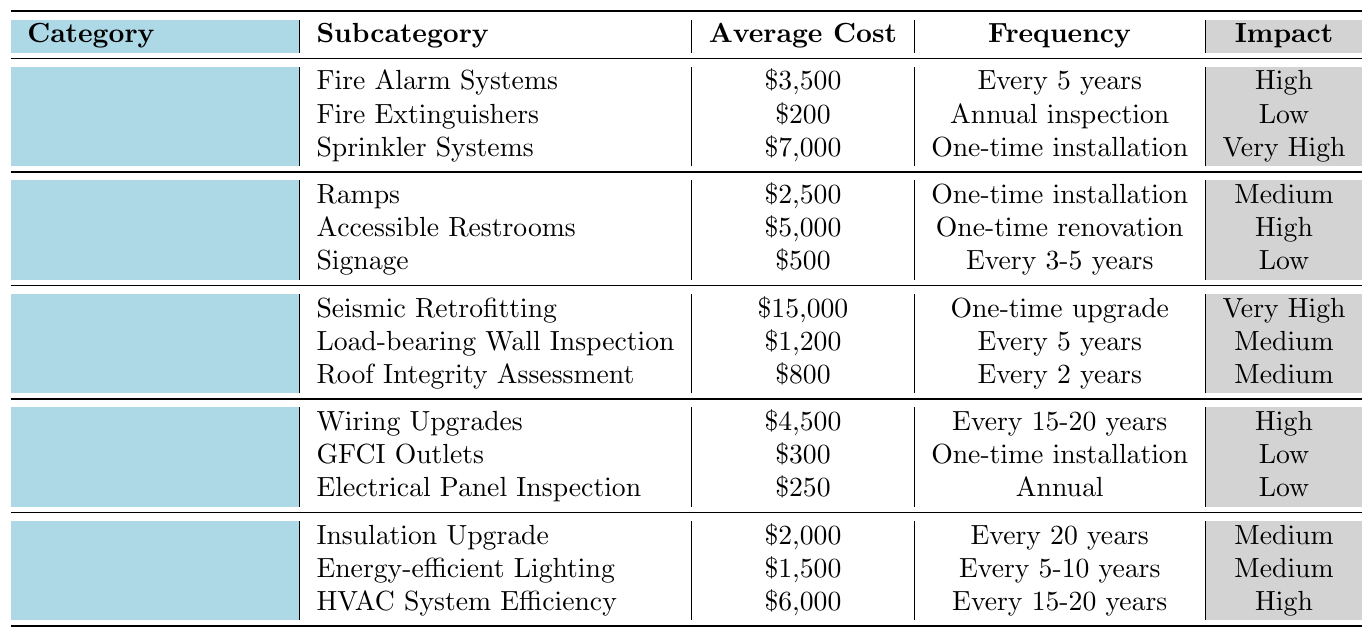What is the average cost of the Fire Safety category? To find the average cost, sum the individual costs: $3,500 (Fire Alarm Systems) + $200 (Fire Extinguishers) + $7,000 (Sprinkler Systems) = $10,700. Then, divide by the number of subcategories (3), which gives $10,700 / 3 = $3,566.67.
Answer: $3,566.67 Which subcategory in Accessibility has the highest impact on small businesses? Reviewing the impact in the Accessibility category, Accessible Restrooms has "High", while Ramps has "Medium" and Signage has "Low". Therefore, Accessible Restrooms is the subcategory with the highest impact.
Answer: Accessible Restrooms How often do Fire Alarm Systems need inspection? The table states that Fire Alarm Systems require inspection every 5 years, as indicated in their frequency column.
Answer: Every 5 years What is the combined cost of structural safety improvements? Sum the costs: $15,000 (Seismic Retrofitting) + $1,200 (Load-bearing Wall Inspection) + $800 (Roof Integrity Assessment) = $17,000 for structural safety improvements.
Answer: $17,000 Do any subcategories in Electrical Systems have a low impact on small businesses? Based on the impact column in Electric Systems, GFCI Outlets and Electrical Panel Inspection both have a "Low" impact on small businesses, so the answer is yes.
Answer: Yes Which category has the one-time installation with the highest average cost? Comparing the one-time installation costs, Sprinkler Systems ($7,000), Ramps ($2,500), and GFCI Outlets ($300), Sprinkler Systems has the highest average cost of $7,000.
Answer: Sprinkler Systems What is the average cost of the Energy Efficiency category? The average cost is calculated as follows: $2,000 (Insulation Upgrade) + $1,500 (Energy-efficient Lighting) + $6,000 (HVAC System Efficiency) = $9,500, which divided by the number of subcategories (3) gives $9,500 / 3 = $3,166.67.
Answer: $3,166.67 Which item requires an annual inspection in Structural Safety? The Load-bearing Wall Inspection is the only item in Structural Safety that needs an inspection every 5 years, not annually, so no item under Structural Safety requires an annual inspection.
Answer: No item requires an annual inspection What is the difference in cost between the highest and lowest subcategories in Fire Safety? The highest cost in Fire Safety is for Sprinkler Systems at $7,000 and the lowest is Fire Extinguishers at $200. The difference is $7,000 - $200 = $6,800.
Answer: $6,800 How many categories have a "Very High" impact rating? In the table, "Very High" impact ratings are found in Fire Safety (Sprinkler Systems) and Structural Safety (Seismic Retrofitting), resulting in a total of two categories with this impact rating.
Answer: 2 categories 